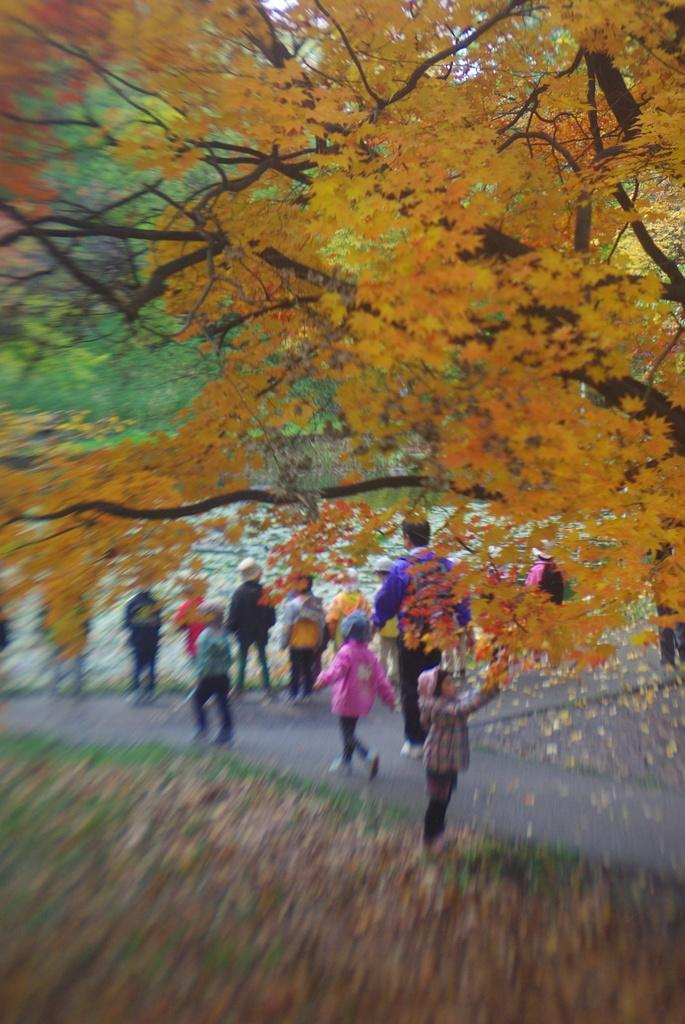What are the main subjects in the image? There are children walking on the road in the image. What can be seen in the background of the image? There are trees in the background of the image. What is present at the bottom of the image? Dry leaves are present at the bottom of the image. What type of sugar is being used by the authority in the image? There is no sugar or authority present in the image. Can you describe the window in the image? There is no window present in the image. 